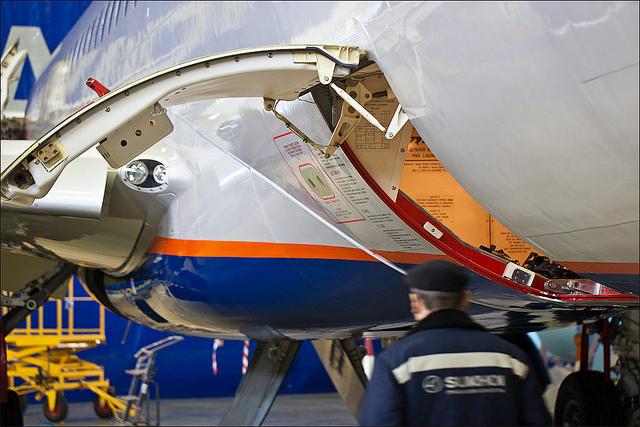Is this a big airplane?
Write a very short answer. Yes. What color is above blue on the plane?
Concise answer only. Orange. Is the plane in the air?
Keep it brief. No. 